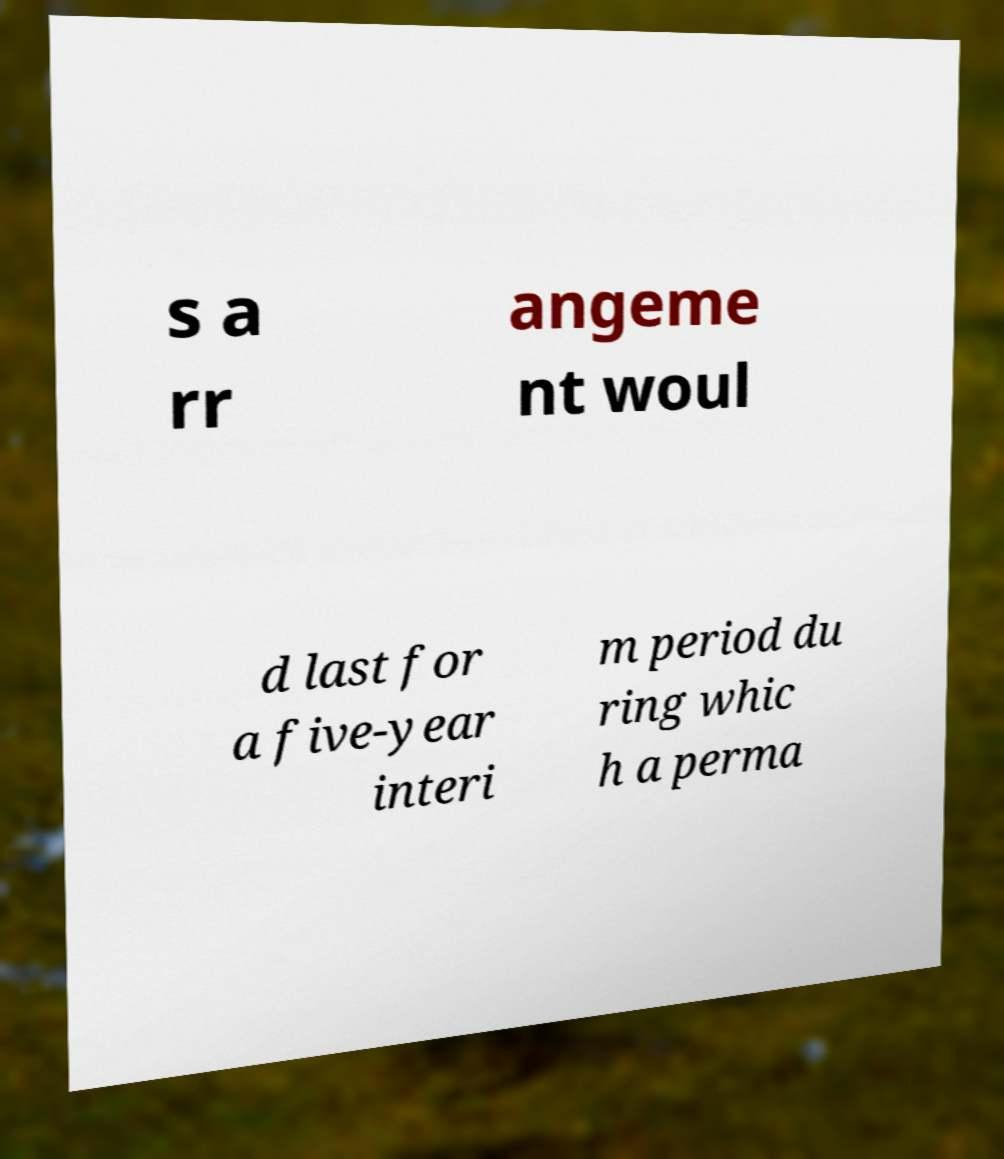Please read and relay the text visible in this image. What does it say? s a rr angeme nt woul d last for a five-year interi m period du ring whic h a perma 